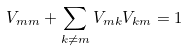Convert formula to latex. <formula><loc_0><loc_0><loc_500><loc_500>V _ { m m } + \sum _ { k \neq m } V _ { m k } V _ { k m } = 1</formula> 